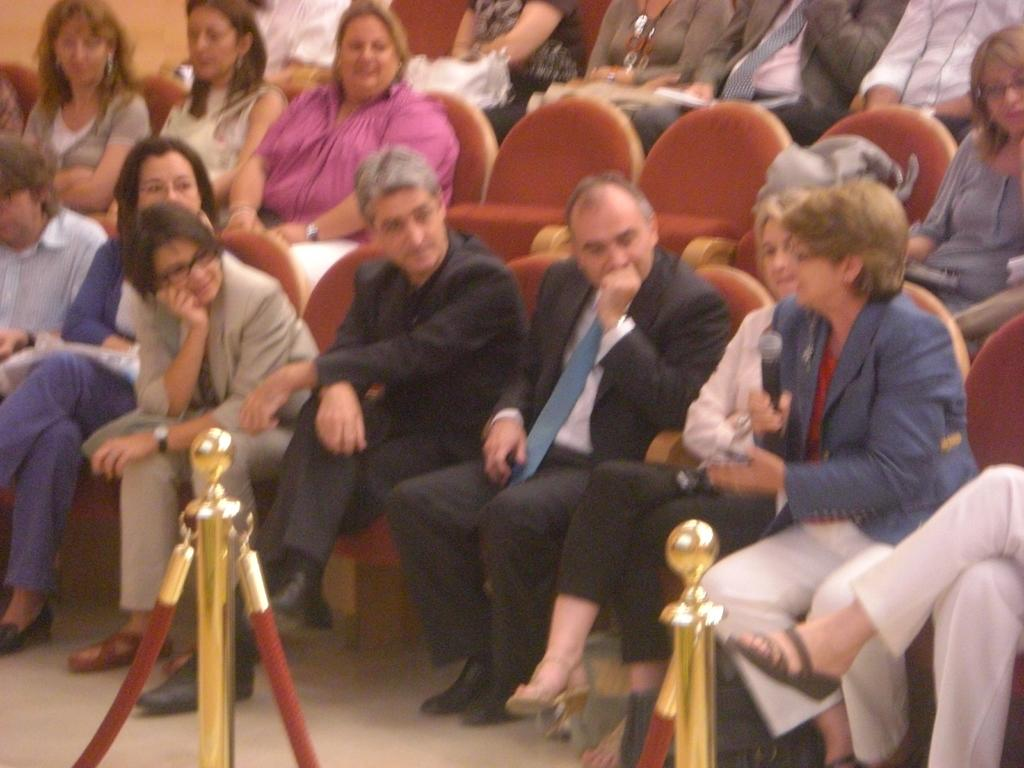What are the people in the image doing? The people in the image are sitting on chairs. What can be seen at the bottom of the image? There is a fence at the bottom of the image. What type of loaf is being baked in the image? There is no loaf or baking activity present in the image. How does the insect blow air in the image? There is no insect present in the image, so it cannot be blowing air. 